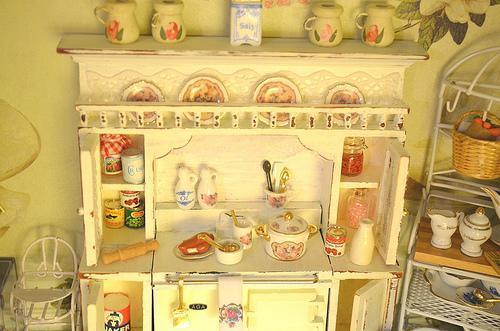How many people are sitting on chair?
Give a very brief answer. 0. 